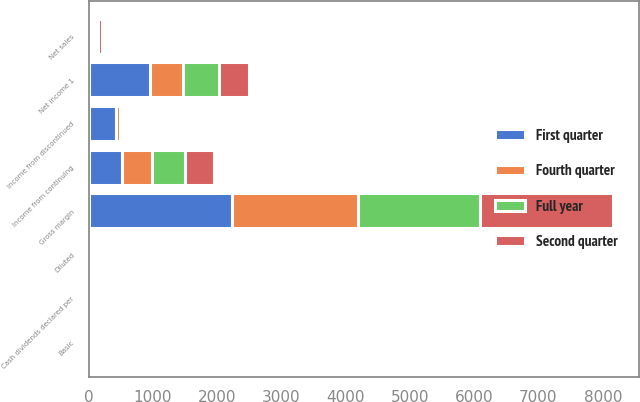Convert chart to OTSL. <chart><loc_0><loc_0><loc_500><loc_500><stacked_bar_chart><ecel><fcel>Net sales<fcel>Gross margin<fcel>Income from continuing<fcel>Basic<fcel>Diluted<fcel>Income from discontinued<fcel>Net income 1<fcel>Cash dividends declared per<nl><fcel>Full year<fcel>50.5<fcel>1891<fcel>507<fcel>0.94<fcel>0.93<fcel>49<fcel>556<fcel>0.49<nl><fcel>Fourth quarter<fcel>50.5<fcel>1969<fcel>468<fcel>0.86<fcel>0.85<fcel>52<fcel>520<fcel>0.52<nl><fcel>Second quarter<fcel>50.5<fcel>2073<fcel>447<fcel>0.83<fcel>0.82<fcel>21<fcel>468<fcel>0.52<nl><fcel>First quarter<fcel>50.5<fcel>2224<fcel>524<fcel>0.97<fcel>0.96<fcel>429<fcel>953<fcel>0.52<nl></chart> 